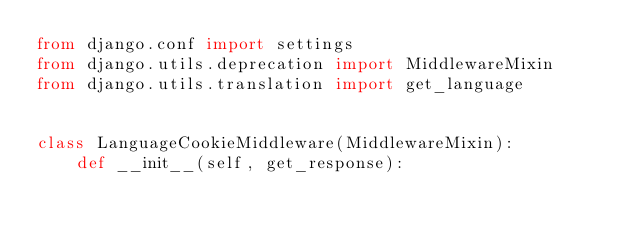Convert code to text. <code><loc_0><loc_0><loc_500><loc_500><_Python_>from django.conf import settings
from django.utils.deprecation import MiddlewareMixin
from django.utils.translation import get_language


class LanguageCookieMiddleware(MiddlewareMixin):
    def __init__(self, get_response):</code> 